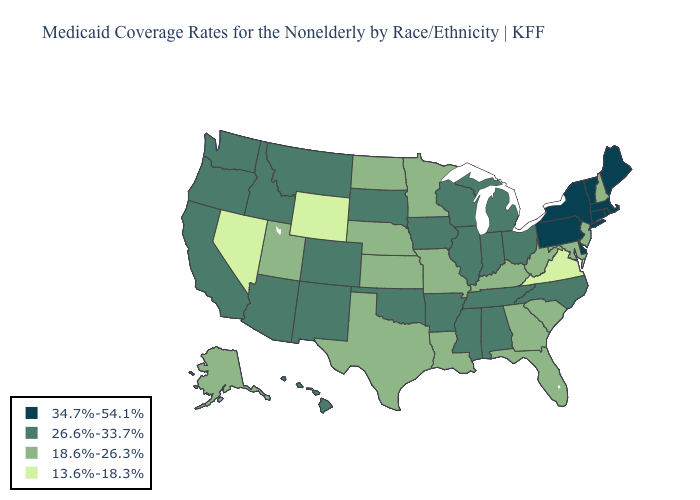What is the highest value in the USA?
Keep it brief. 34.7%-54.1%. Which states have the lowest value in the West?
Short answer required. Nevada, Wyoming. Does Minnesota have the same value as California?
Give a very brief answer. No. Does Vermont have the highest value in the USA?
Be succinct. Yes. Is the legend a continuous bar?
Write a very short answer. No. Does Idaho have the same value as Colorado?
Write a very short answer. Yes. Name the states that have a value in the range 18.6%-26.3%?
Give a very brief answer. Alaska, Florida, Georgia, Kansas, Kentucky, Louisiana, Maryland, Minnesota, Missouri, Nebraska, New Hampshire, New Jersey, North Dakota, South Carolina, Texas, Utah, West Virginia. Name the states that have a value in the range 26.6%-33.7%?
Be succinct. Alabama, Arizona, Arkansas, California, Colorado, Hawaii, Idaho, Illinois, Indiana, Iowa, Michigan, Mississippi, Montana, New Mexico, North Carolina, Ohio, Oklahoma, Oregon, South Dakota, Tennessee, Washington, Wisconsin. What is the highest value in the West ?
Keep it brief. 26.6%-33.7%. Name the states that have a value in the range 26.6%-33.7%?
Quick response, please. Alabama, Arizona, Arkansas, California, Colorado, Hawaii, Idaho, Illinois, Indiana, Iowa, Michigan, Mississippi, Montana, New Mexico, North Carolina, Ohio, Oklahoma, Oregon, South Dakota, Tennessee, Washington, Wisconsin. What is the highest value in the USA?
Quick response, please. 34.7%-54.1%. What is the highest value in the MidWest ?
Write a very short answer. 26.6%-33.7%. Name the states that have a value in the range 18.6%-26.3%?
Quick response, please. Alaska, Florida, Georgia, Kansas, Kentucky, Louisiana, Maryland, Minnesota, Missouri, Nebraska, New Hampshire, New Jersey, North Dakota, South Carolina, Texas, Utah, West Virginia. Name the states that have a value in the range 26.6%-33.7%?
Quick response, please. Alabama, Arizona, Arkansas, California, Colorado, Hawaii, Idaho, Illinois, Indiana, Iowa, Michigan, Mississippi, Montana, New Mexico, North Carolina, Ohio, Oklahoma, Oregon, South Dakota, Tennessee, Washington, Wisconsin. What is the lowest value in states that border South Carolina?
Give a very brief answer. 18.6%-26.3%. 